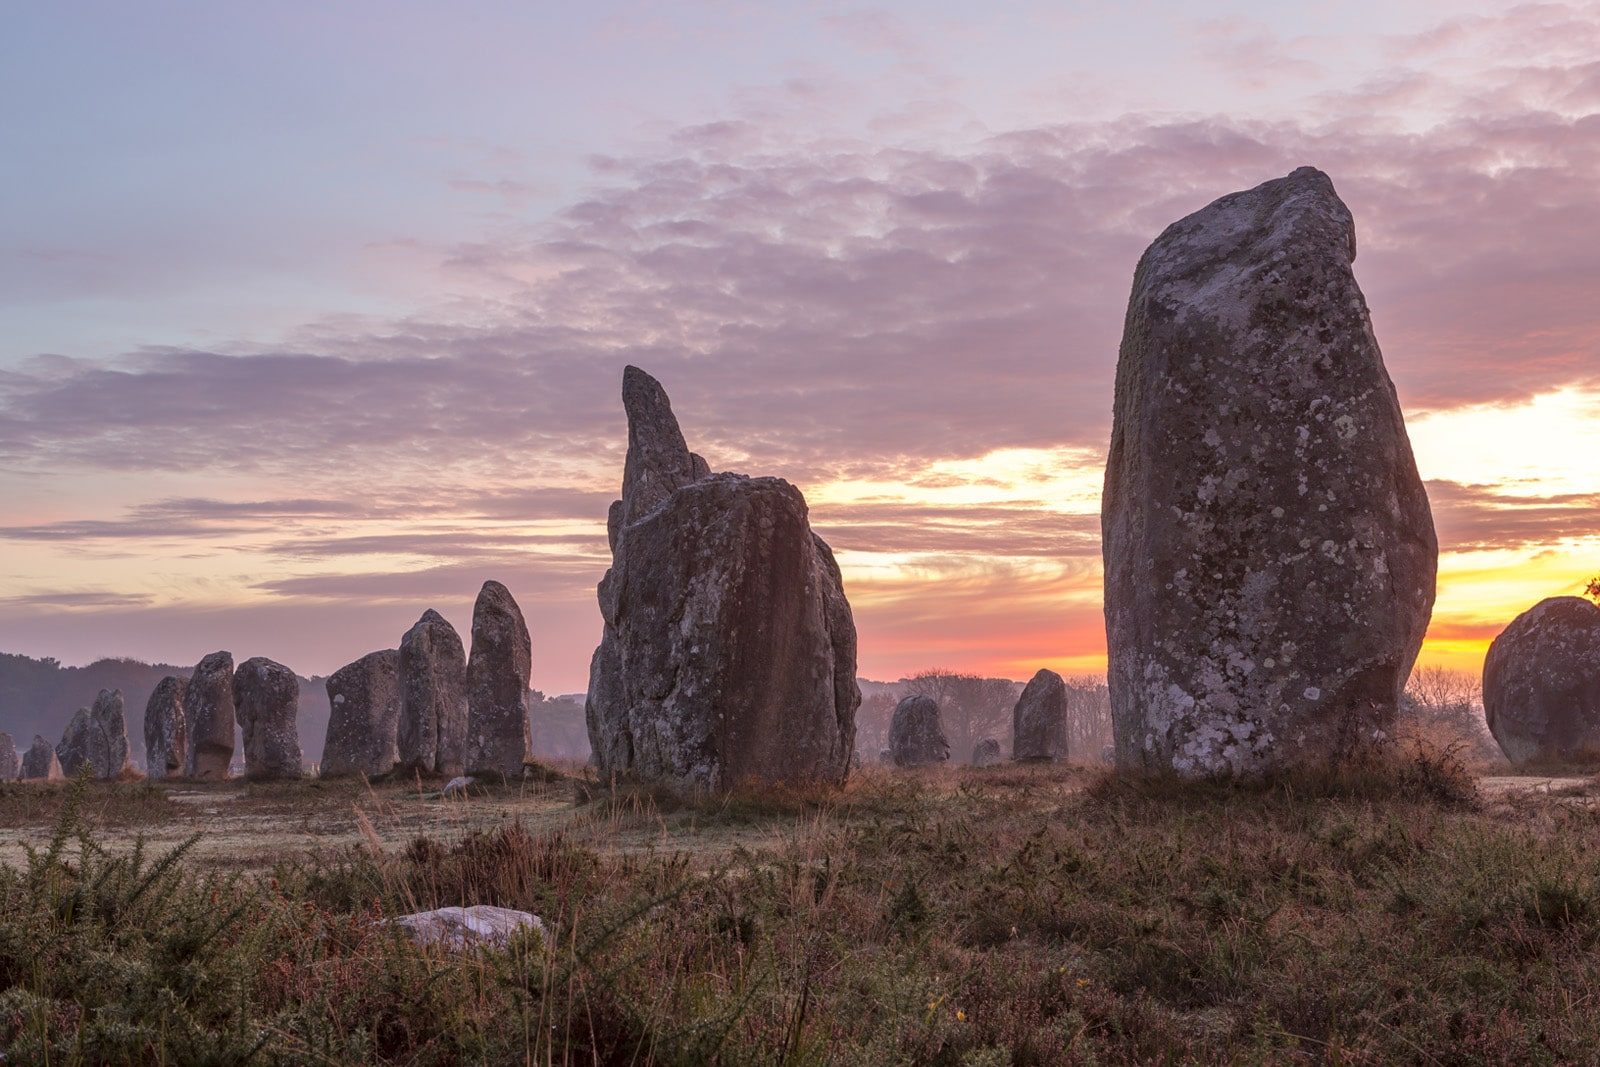What kind of flora or fauna can be found in the area around the Carnac stones? The landscape around the Carnac stones is typical of the Brittany region and includes a rich variety of flora and fauna. The area is characterized by heathland and meadows, where you can find various grasses, heathers, and wildflowers. In the spring and summer, the fields come alive with an array of colorful flowers and buzzing insects. The fauna includes a variety of bird species such as skylarks, warblers, and kestrels. Small mammals like hares and rabbits can often be seen, and the occasional fox might make a stealthy appearance. Additionally, the surrounding woodlands and hedgerows provide habitats for many species of reptiles, amphibians, and insects. This biodiverse environment adds to the natural beauty and tranquility of the Carnac stone setting. Can you create a short poem inspired by this image? In Brittany's dawn, where stones align,
Ancient whispers through time entwine.
Their shadows stretch with morning's glow,
Mysteries from long ago.
Grass and heather gently sway,
As birds greet the break of day.
Silent sentinels, they stand tall,
Guardians of secrets, revealing all. If I wanted to visit this site, what should I keep in mind? When planning a visit to the Carnac stones, there are several considerations to ensure a memorable and respectful experience. Firstly, it's important to check the opening hours and any entry fees, as access to some areas may be restricted or require a guided tour. Wear comfortable walking shoes, as the site covers a large area with uneven terrain. The best times to visit are early in the morning or late in the afternoon to avoid crowds and capture the beautiful light during sunrise or sunset. Respect the site's historical significance by not climbing on the stones and adhering to any guidelines provided. Bringing a camera is a must, as the scenery is breathtaking. Make sure to stay hydrated and use sun protection, as the open fields can get quite sunny. Lastly, take a moment to reflect on the history and significance of this ancient site, letting the atmosphere transport you back thousands of years. 